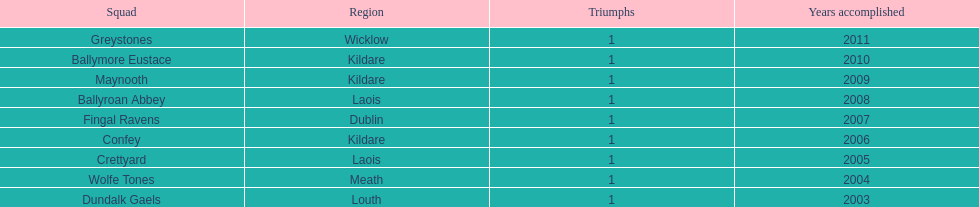What is the years won for each team 2011, 2010, 2009, 2008, 2007, 2006, 2005, 2004, 2003. 